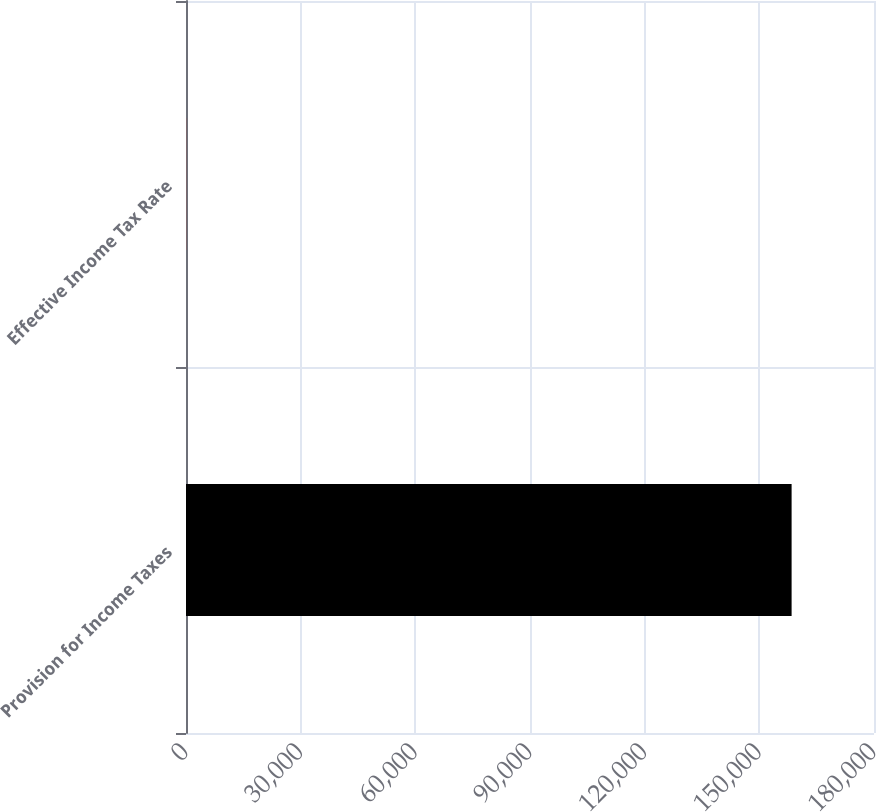Convert chart to OTSL. <chart><loc_0><loc_0><loc_500><loc_500><bar_chart><fcel>Provision for Income Taxes<fcel>Effective Income Tax Rate<nl><fcel>158444<fcel>24<nl></chart> 